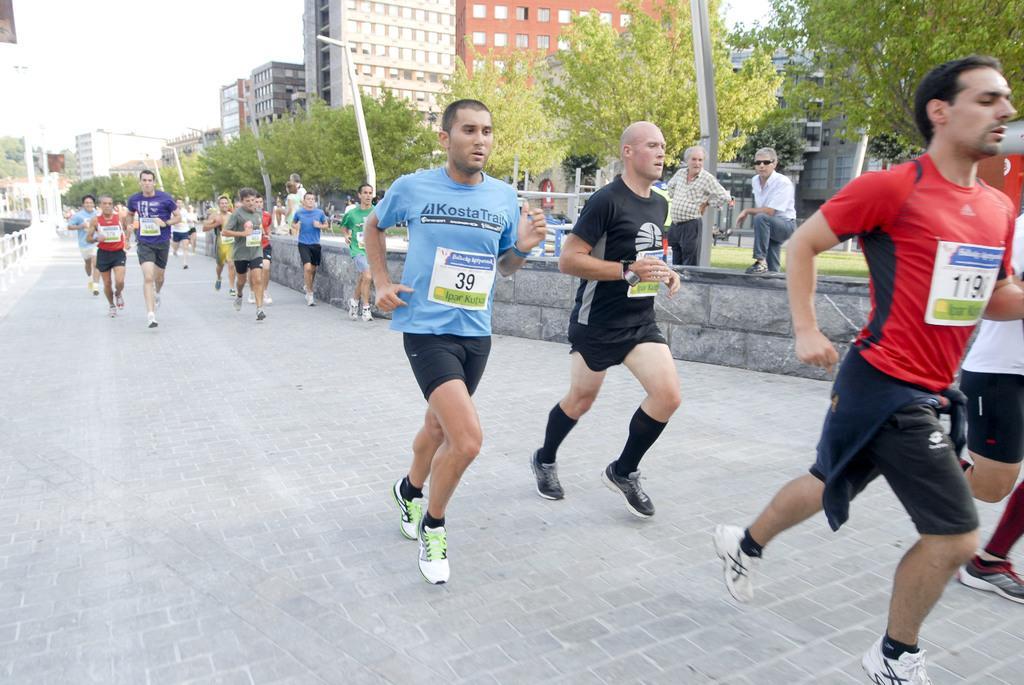Could you give a brief overview of what you see in this image? In this image there are some persons running in middle of this image and there are some trees in the background. There are two persons standing on the right side of this image. There is a road in the bottom of this image and there are some buildings on the top of this image. There is a sky on the top left side of this image. 